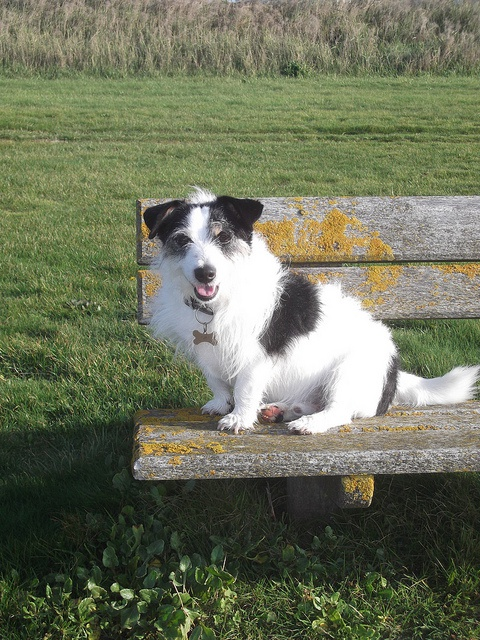Describe the objects in this image and their specific colors. I can see bench in gray, darkgray, tan, and black tones and dog in gray, white, darkgray, and black tones in this image. 